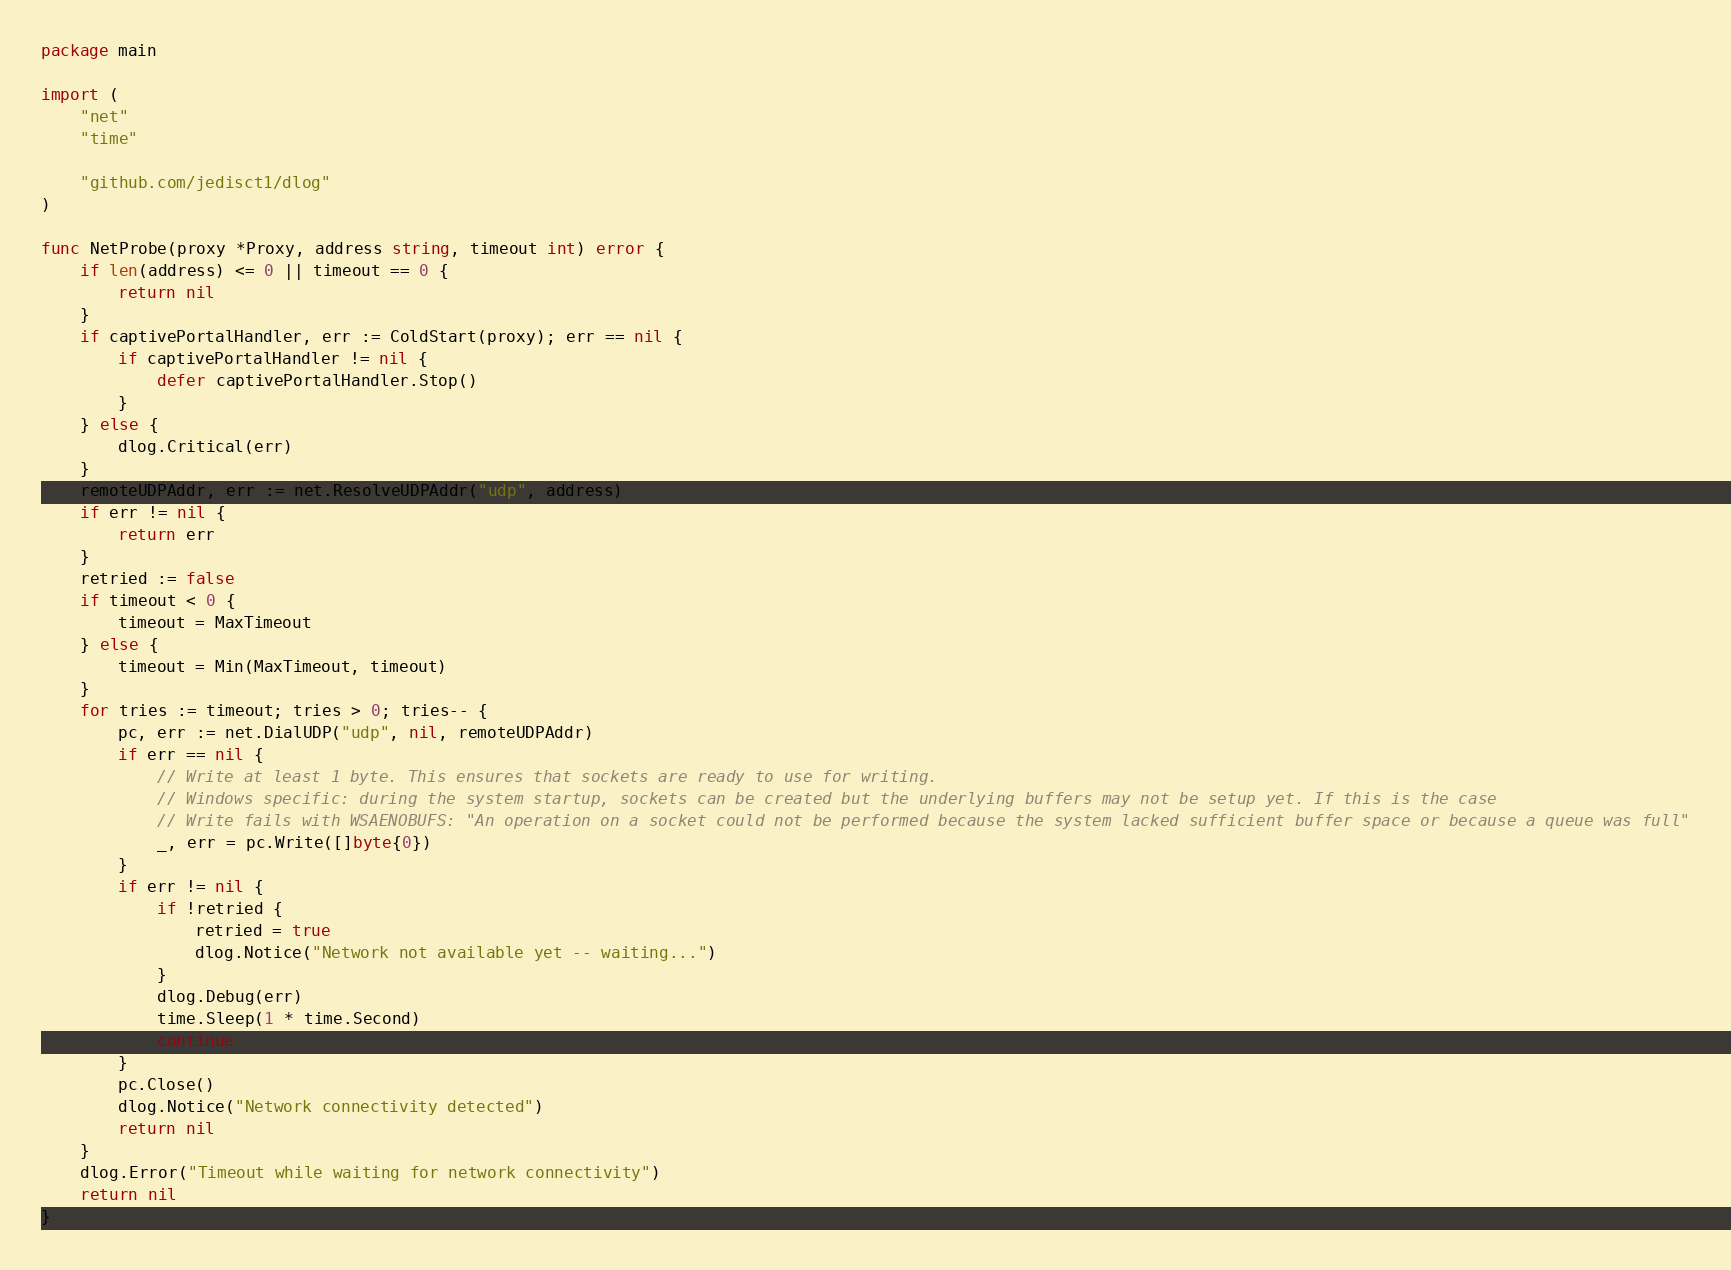<code> <loc_0><loc_0><loc_500><loc_500><_Go_>package main

import (
	"net"
	"time"

	"github.com/jedisct1/dlog"
)

func NetProbe(proxy *Proxy, address string, timeout int) error {
	if len(address) <= 0 || timeout == 0 {
		return nil
	}
	if captivePortalHandler, err := ColdStart(proxy); err == nil {
		if captivePortalHandler != nil {
			defer captivePortalHandler.Stop()
		}
	} else {
		dlog.Critical(err)
	}
	remoteUDPAddr, err := net.ResolveUDPAddr("udp", address)
	if err != nil {
		return err
	}
	retried := false
	if timeout < 0 {
		timeout = MaxTimeout
	} else {
		timeout = Min(MaxTimeout, timeout)
	}
	for tries := timeout; tries > 0; tries-- {
		pc, err := net.DialUDP("udp", nil, remoteUDPAddr)
		if err == nil {
			// Write at least 1 byte. This ensures that sockets are ready to use for writing.
			// Windows specific: during the system startup, sockets can be created but the underlying buffers may not be setup yet. If this is the case
			// Write fails with WSAENOBUFS: "An operation on a socket could not be performed because the system lacked sufficient buffer space or because a queue was full"
			_, err = pc.Write([]byte{0})
		}
		if err != nil {
			if !retried {
				retried = true
				dlog.Notice("Network not available yet -- waiting...")
			}
			dlog.Debug(err)
			time.Sleep(1 * time.Second)
			continue
		}
		pc.Close()
		dlog.Notice("Network connectivity detected")
		return nil
	}
	dlog.Error("Timeout while waiting for network connectivity")
	return nil
}
</code> 